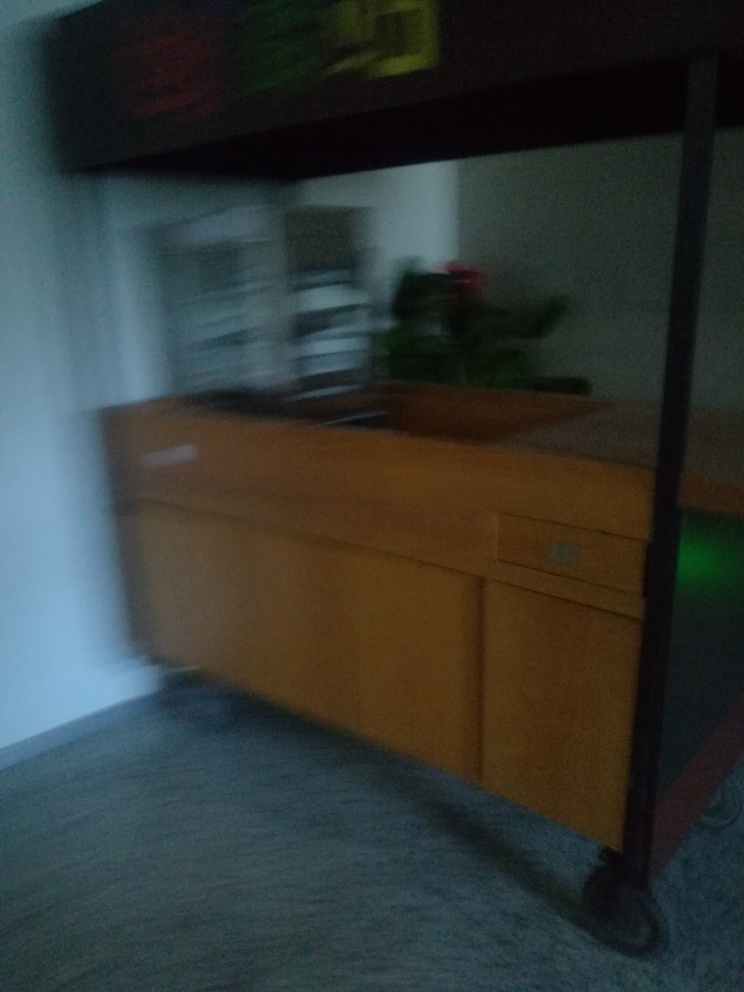What might be the emotional or artistic impact of such a blurred image? The emotional or artistic impact of a blurred image can vary. It might evoke feelings of haste, confusion, or chaos, leaving much to the viewer's interpretation. Artistically, it could be used to express movement or the passing of time, to create a dreamlike quality, or to focus attention away from specific details and towards mood and atmosphere. 